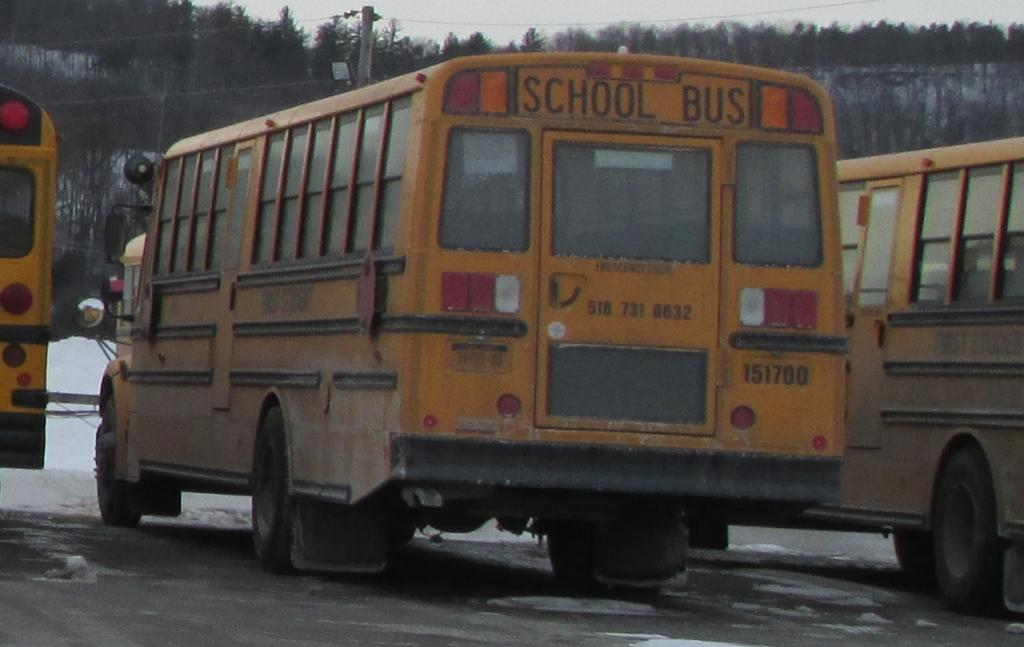How many school buses can be seen in the image? There are three school buses in the image. What color are the school buses? The school buses are yellow in color. Where are the school buses located in the image? The school buses are on the road. What can be seen in the background of the image? There is snow, an electric pole, and trees visible in the background of the image. What type of riddle is being solved by the school buses in the image? There is no riddle being solved by the school buses in the image; they are simply parked on the road. Can you tell me how many beds are visible in the image? There are no beds present in the image. 